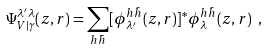<formula> <loc_0><loc_0><loc_500><loc_500>\Psi _ { V | \gamma } ^ { \lambda ^ { \prime } \lambda } ( z , r ) = \sum _ { h \bar { h } } [ \phi _ { \lambda ^ { \prime } } ^ { h \bar { h } } ( z , r ) ] ^ { * } \phi _ { \lambda } ^ { h \bar { h } } ( z , r ) \ ,</formula> 